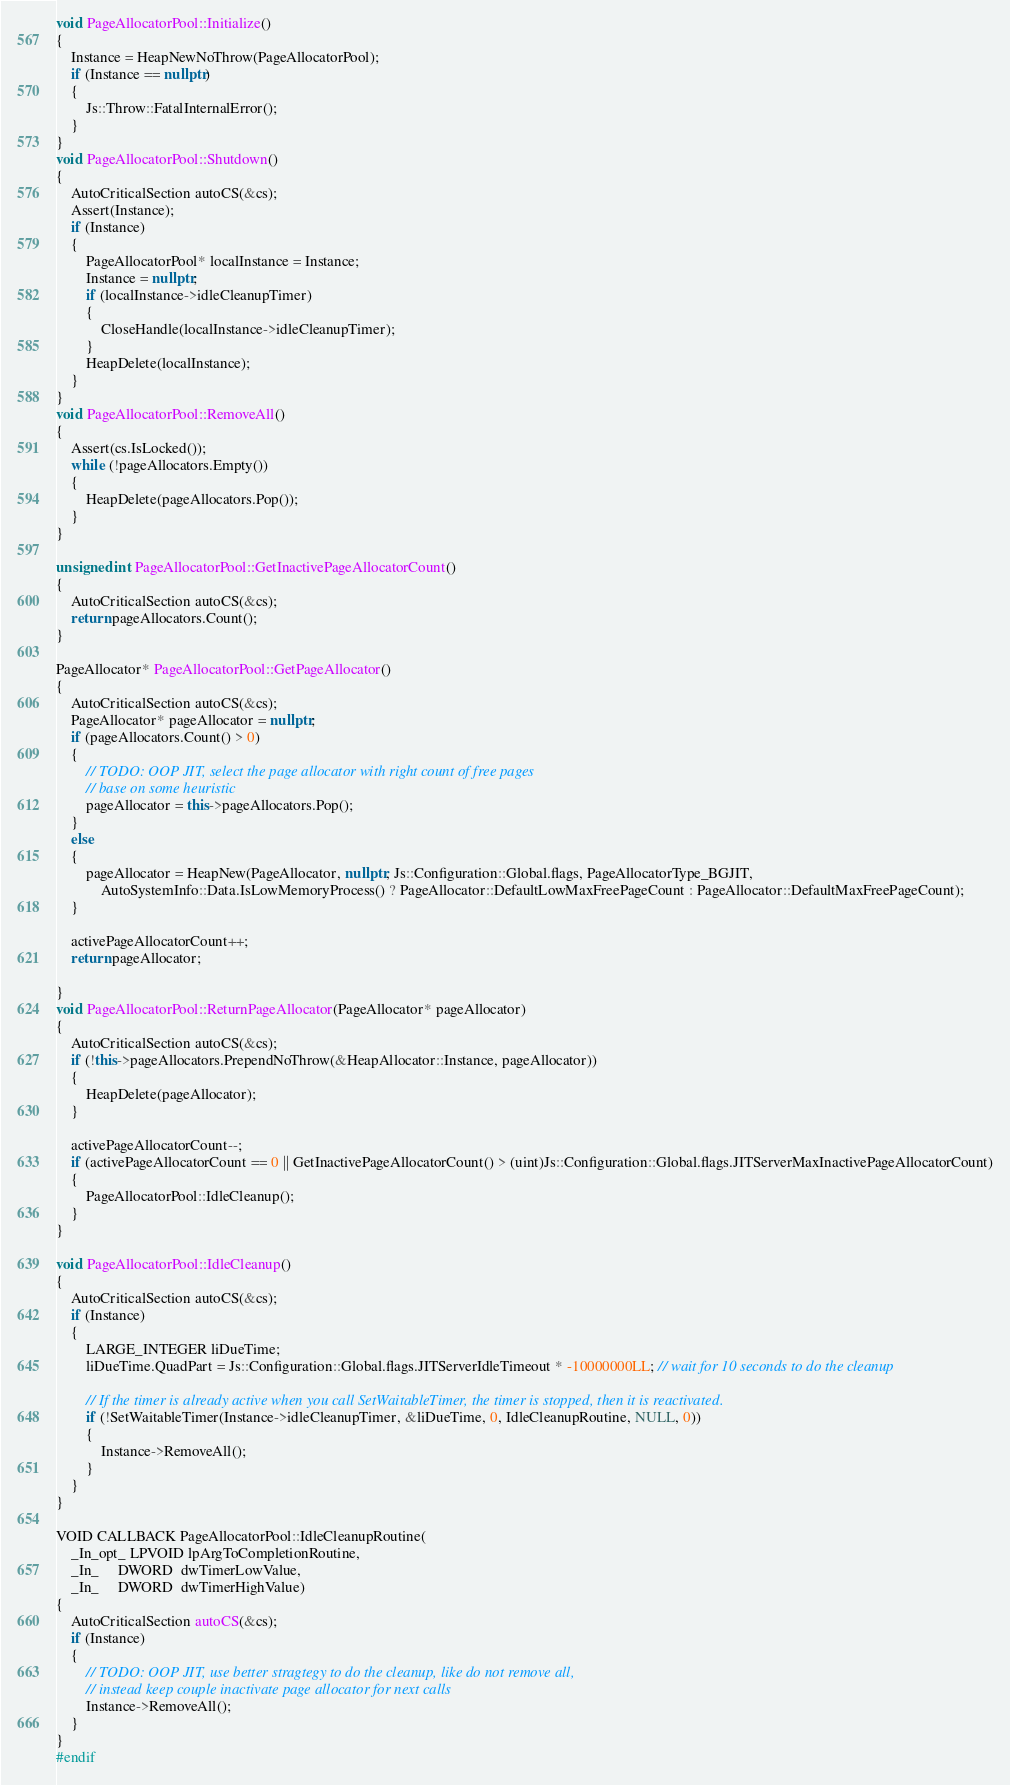Convert code to text. <code><loc_0><loc_0><loc_500><loc_500><_C++_>
void PageAllocatorPool::Initialize()
{
    Instance = HeapNewNoThrow(PageAllocatorPool);
    if (Instance == nullptr)
    {
        Js::Throw::FatalInternalError();
    }
}
void PageAllocatorPool::Shutdown()
{
    AutoCriticalSection autoCS(&cs);
    Assert(Instance);
    if (Instance)
    {
        PageAllocatorPool* localInstance = Instance;
        Instance = nullptr;
        if (localInstance->idleCleanupTimer)
        {
            CloseHandle(localInstance->idleCleanupTimer);
        }
        HeapDelete(localInstance);
    }
}
void PageAllocatorPool::RemoveAll()
{
    Assert(cs.IsLocked());
    while (!pageAllocators.Empty())
    {
        HeapDelete(pageAllocators.Pop());
    }
}

unsigned int PageAllocatorPool::GetInactivePageAllocatorCount()
{
    AutoCriticalSection autoCS(&cs);
    return pageAllocators.Count();
}

PageAllocator* PageAllocatorPool::GetPageAllocator()
{
    AutoCriticalSection autoCS(&cs);
    PageAllocator* pageAllocator = nullptr;
    if (pageAllocators.Count() > 0)
    {
        // TODO: OOP JIT, select the page allocator with right count of free pages
        // base on some heuristic
        pageAllocator = this->pageAllocators.Pop();
    }
    else
    {
        pageAllocator = HeapNew(PageAllocator, nullptr, Js::Configuration::Global.flags, PageAllocatorType_BGJIT,
            AutoSystemInfo::Data.IsLowMemoryProcess() ? PageAllocator::DefaultLowMaxFreePageCount : PageAllocator::DefaultMaxFreePageCount);
    }

    activePageAllocatorCount++;
    return pageAllocator;

}
void PageAllocatorPool::ReturnPageAllocator(PageAllocator* pageAllocator)
{
    AutoCriticalSection autoCS(&cs);
    if (!this->pageAllocators.PrependNoThrow(&HeapAllocator::Instance, pageAllocator))
    {
        HeapDelete(pageAllocator);
    }

    activePageAllocatorCount--;
    if (activePageAllocatorCount == 0 || GetInactivePageAllocatorCount() > (uint)Js::Configuration::Global.flags.JITServerMaxInactivePageAllocatorCount)
    {
        PageAllocatorPool::IdleCleanup();
    }
}

void PageAllocatorPool::IdleCleanup()
{
    AutoCriticalSection autoCS(&cs);
    if (Instance)
    {
        LARGE_INTEGER liDueTime;
        liDueTime.QuadPart = Js::Configuration::Global.flags.JITServerIdleTimeout * -10000000LL; // wait for 10 seconds to do the cleanup

        // If the timer is already active when you call SetWaitableTimer, the timer is stopped, then it is reactivated.
        if (!SetWaitableTimer(Instance->idleCleanupTimer, &liDueTime, 0, IdleCleanupRoutine, NULL, 0))
        {
            Instance->RemoveAll();
        }
    }
}

VOID CALLBACK PageAllocatorPool::IdleCleanupRoutine(
    _In_opt_ LPVOID lpArgToCompletionRoutine,
    _In_     DWORD  dwTimerLowValue,
    _In_     DWORD  dwTimerHighValue)
{
    AutoCriticalSection autoCS(&cs);
    if (Instance)
    {
        // TODO: OOP JIT, use better stragtegy to do the cleanup, like do not remove all,
        // instead keep couple inactivate page allocator for next calls
        Instance->RemoveAll();
    }
}
#endif
</code> 